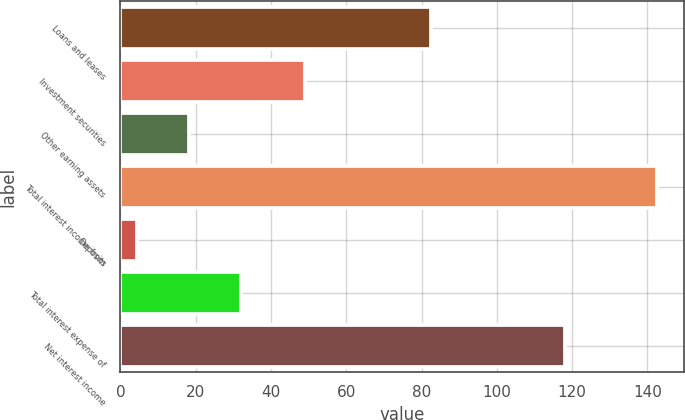<chart> <loc_0><loc_0><loc_500><loc_500><bar_chart><fcel>Loans and leases<fcel>Investment securities<fcel>Other earning assets<fcel>Total interest income from<fcel>Deposits<fcel>Total interest expense of<fcel>Net interest income<nl><fcel>82.5<fcel>49<fcel>18.13<fcel>142.6<fcel>4.3<fcel>31.96<fcel>118.1<nl></chart> 